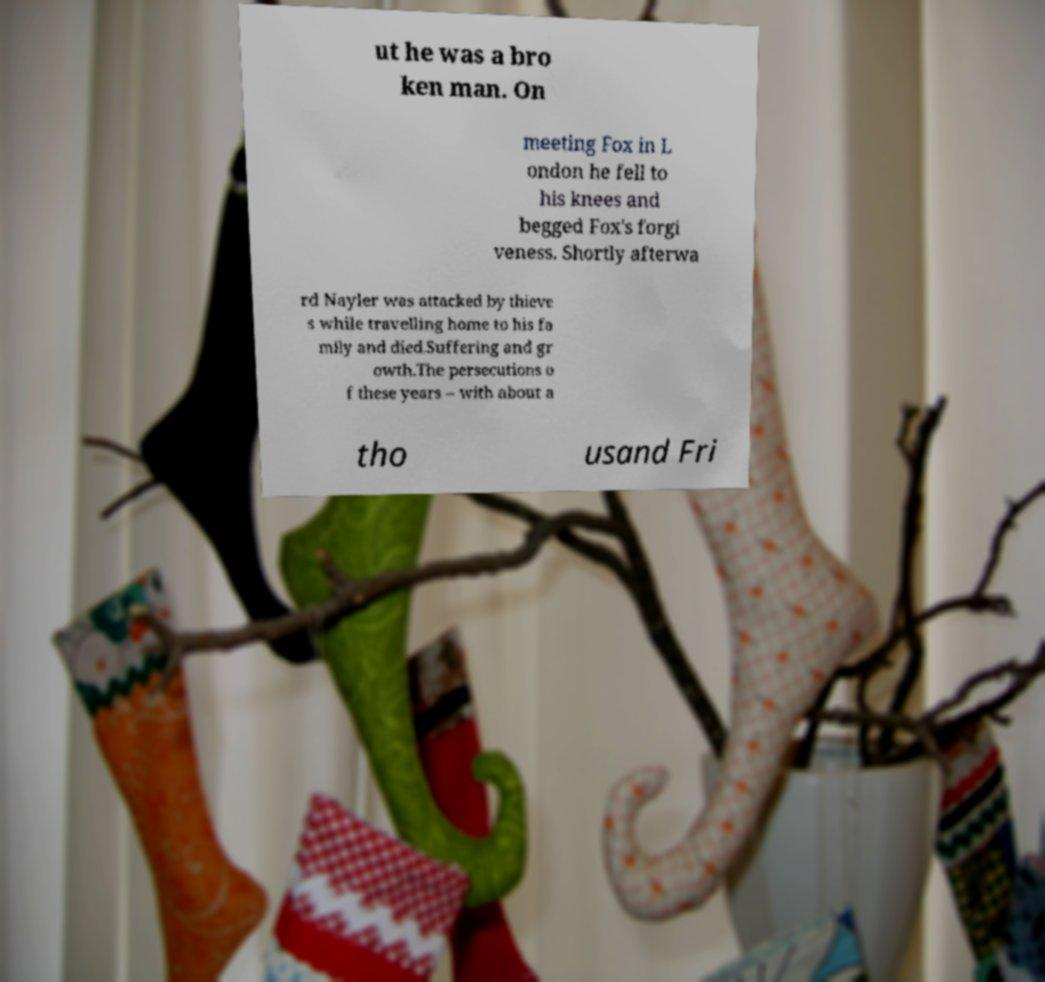For documentation purposes, I need the text within this image transcribed. Could you provide that? ut he was a bro ken man. On meeting Fox in L ondon he fell to his knees and begged Fox's forgi veness. Shortly afterwa rd Nayler was attacked by thieve s while travelling home to his fa mily and died.Suffering and gr owth.The persecutions o f these years – with about a tho usand Fri 